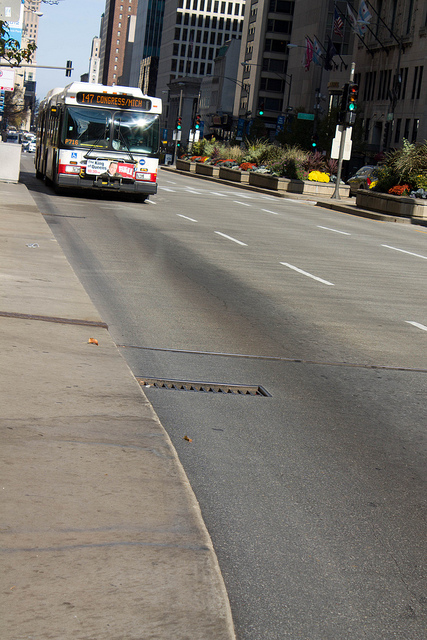Read and extract the text from this image. 147 